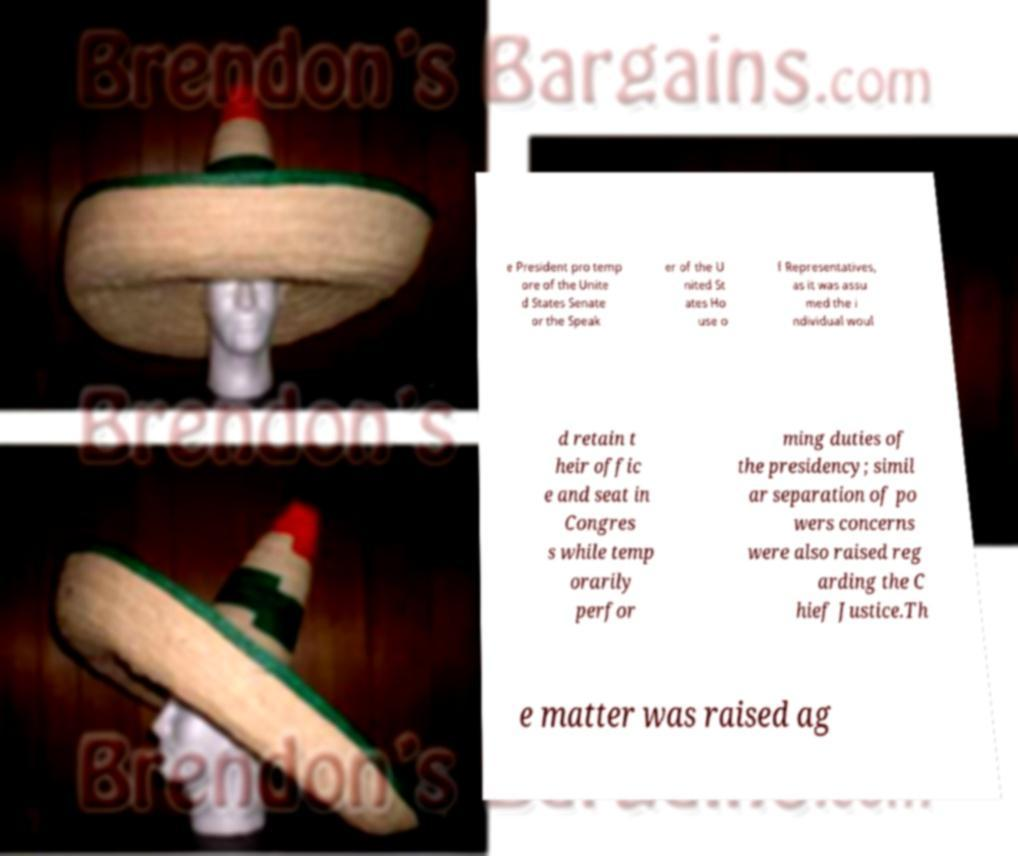Can you read and provide the text displayed in the image?This photo seems to have some interesting text. Can you extract and type it out for me? e President pro temp ore of the Unite d States Senate or the Speak er of the U nited St ates Ho use o f Representatives, as it was assu med the i ndividual woul d retain t heir offic e and seat in Congres s while temp orarily perfor ming duties of the presidency; simil ar separation of po wers concerns were also raised reg arding the C hief Justice.Th e matter was raised ag 